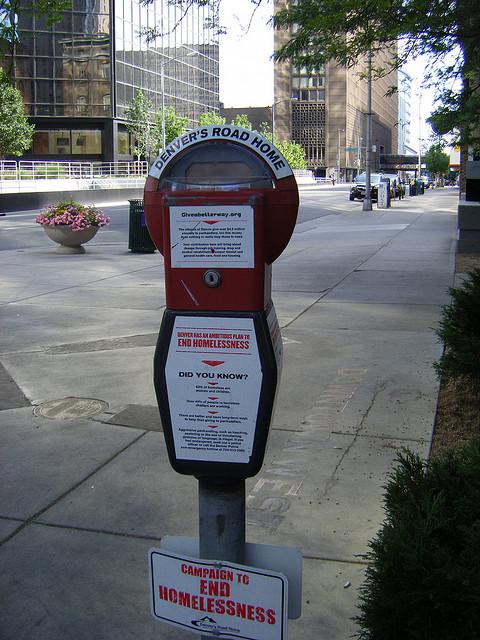What is this mechanism for?
Answer briefly. Parking meter. What color are the flowers in the planter?
Keep it brief. Pink. What city is this?
Be succinct. Denver. 